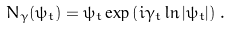Convert formula to latex. <formula><loc_0><loc_0><loc_500><loc_500>N _ { \gamma } ( \psi _ { t } ) = \psi _ { t } \exp \left ( i \gamma _ { t } \ln | \psi _ { t } | \right ) \, .</formula> 